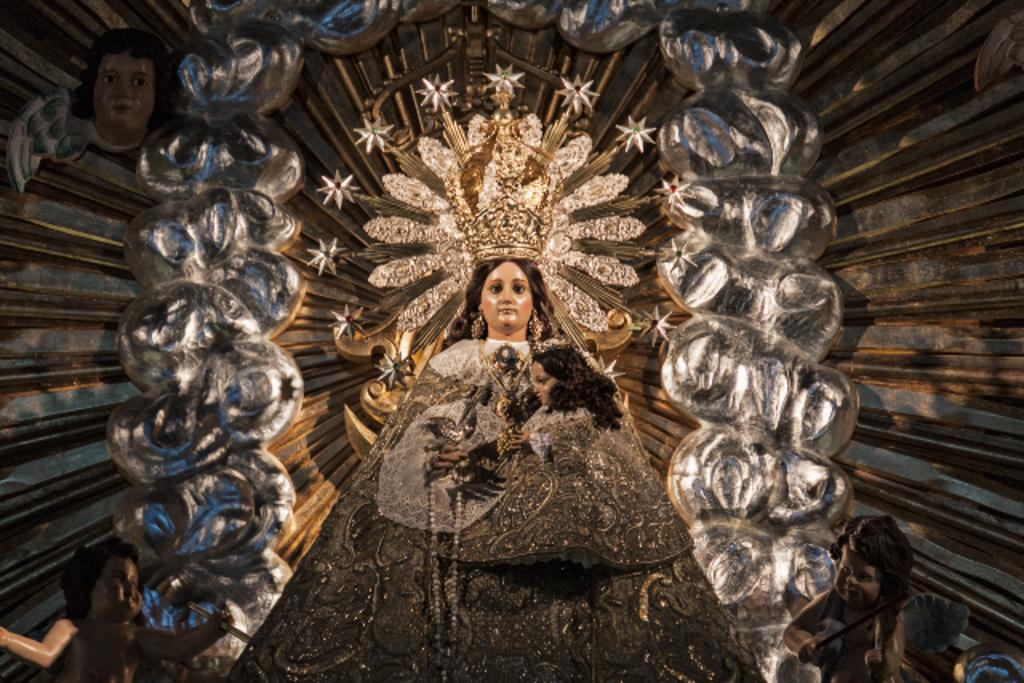What type of objects can be seen in the image? There are sculptures in the image. What type of key is used to unlock the motion of the grape in the image? There is no key, motion, or grape present in the image; it only features sculptures. 